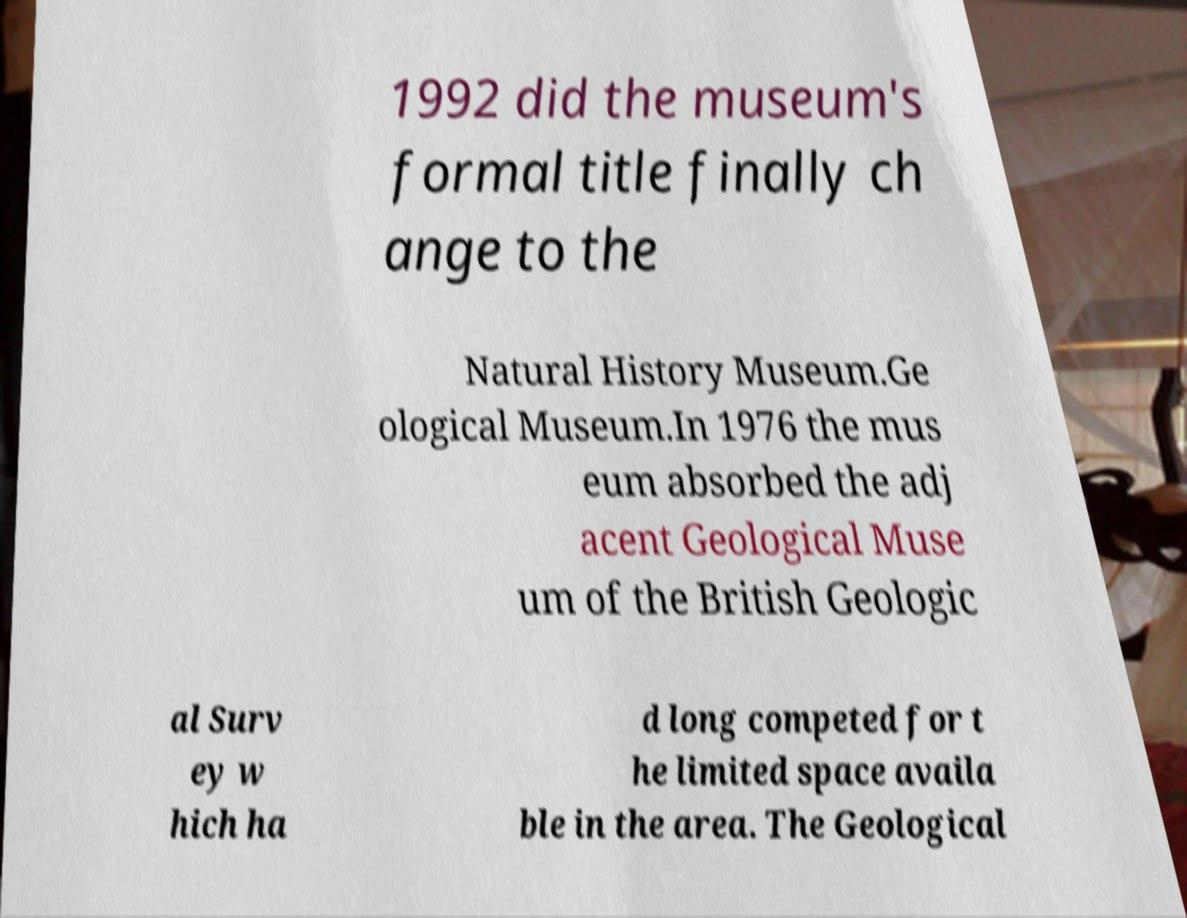For documentation purposes, I need the text within this image transcribed. Could you provide that? 1992 did the museum's formal title finally ch ange to the Natural History Museum.Ge ological Museum.In 1976 the mus eum absorbed the adj acent Geological Muse um of the British Geologic al Surv ey w hich ha d long competed for t he limited space availa ble in the area. The Geological 